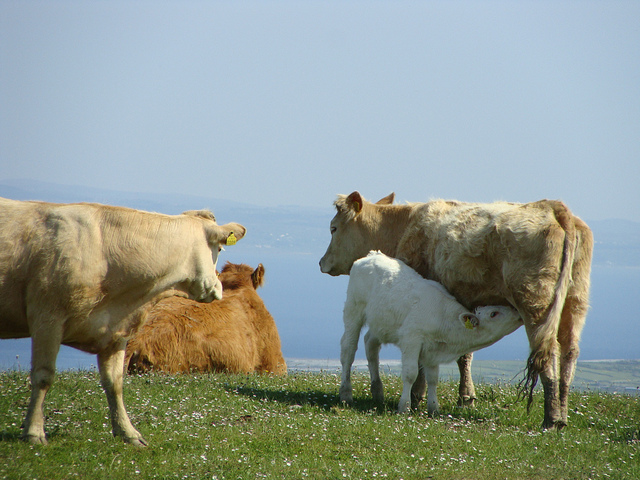<image>Which sheep is the oldest? It is unknown which sheep is the oldest. Which sheep is the oldest? I am not sure which sheep is the oldest. However, it can be seen that the one lying down, the brown sheep, the mother sheep, or the white sheep could be the oldest. 